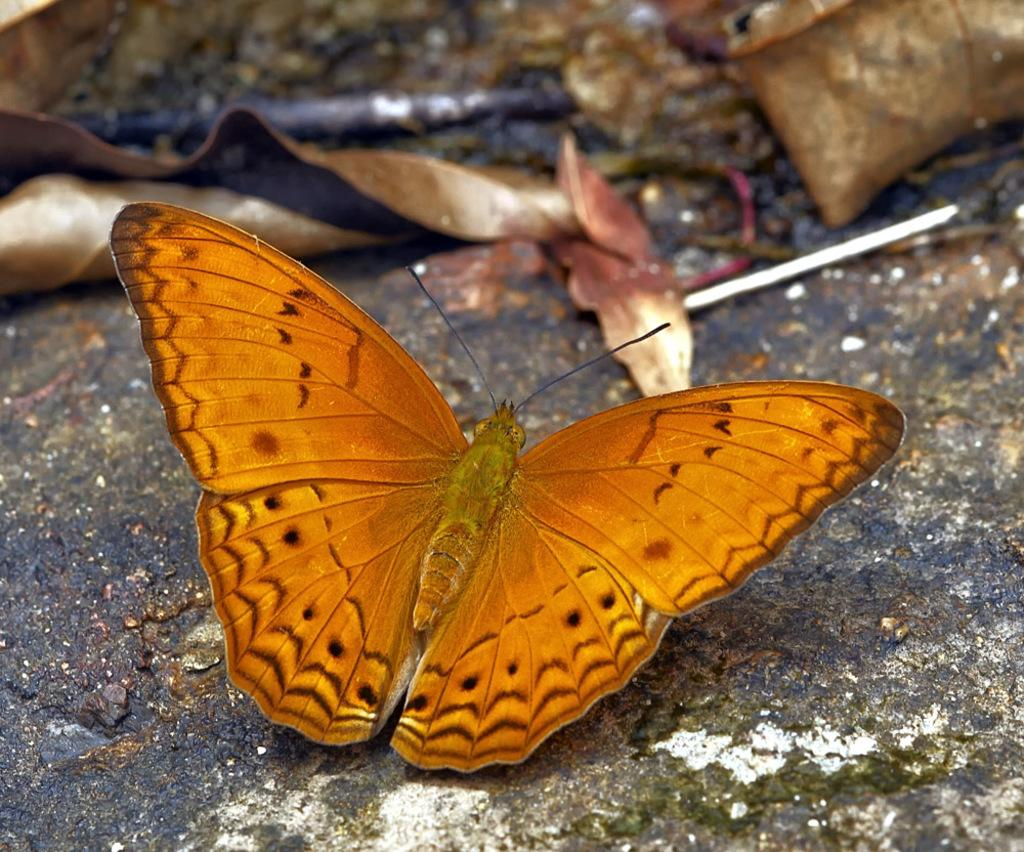What type of creature is in the image? There is a butterfly in the image. What colors can be seen on the butterfly? The butterfly has orange and black colors. Where is the butterfly located in the image? The butterfly is on the land. What can be seen in the background of the image? Dried leaves are visible in the background of the image. Can you tell me how many visitors are waiting to join the butterfly in the image? There are no visitors present in the image, and the butterfly is not waiting for anyone to join it. 